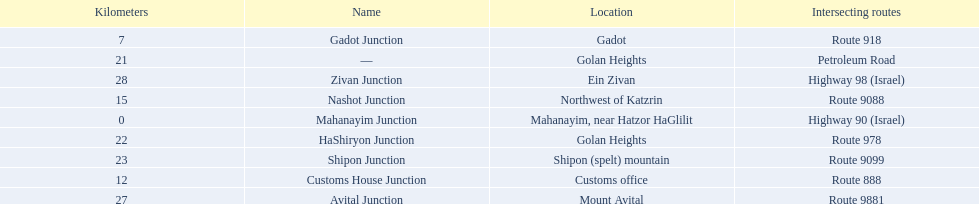What are all the are all the locations on the highway 91 (israel)? Mahanayim, near Hatzor HaGlilit, Gadot, Customs office, Northwest of Katzrin, Golan Heights, Golan Heights, Shipon (spelt) mountain, Mount Avital, Ein Zivan. What are the distance values in kilometers for ein zivan, gadot junction and shipon junction? 7, 23, 28. Which is the least distance away? 7. What is the name? Gadot Junction. 